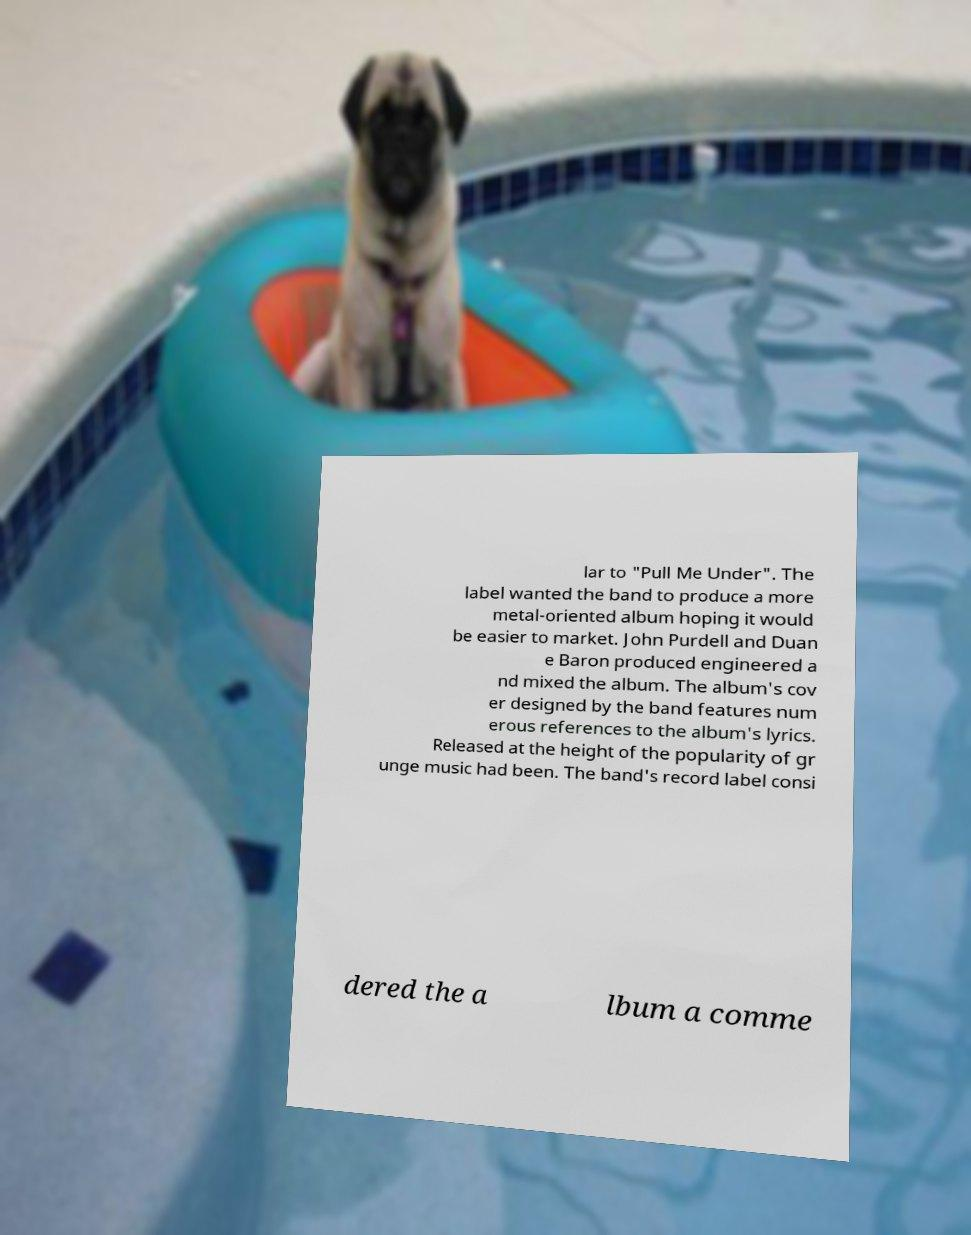Please identify and transcribe the text found in this image. lar to "Pull Me Under". The label wanted the band to produce a more metal-oriented album hoping it would be easier to market. John Purdell and Duan e Baron produced engineered a nd mixed the album. The album's cov er designed by the band features num erous references to the album's lyrics. Released at the height of the popularity of gr unge music had been. The band's record label consi dered the a lbum a comme 